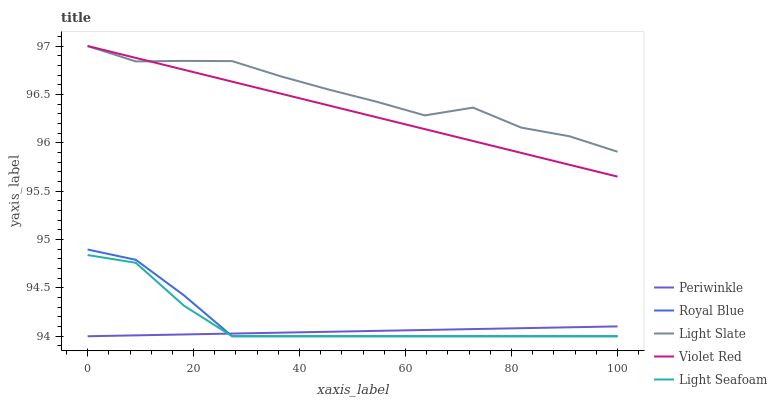Does Royal Blue have the minimum area under the curve?
Answer yes or no. No. Does Royal Blue have the maximum area under the curve?
Answer yes or no. No. Is Royal Blue the smoothest?
Answer yes or no. No. Is Royal Blue the roughest?
Answer yes or no. No. Does Violet Red have the lowest value?
Answer yes or no. No. Does Royal Blue have the highest value?
Answer yes or no. No. Is Light Seafoam less than Violet Red?
Answer yes or no. Yes. Is Violet Red greater than Light Seafoam?
Answer yes or no. Yes. Does Light Seafoam intersect Violet Red?
Answer yes or no. No. 